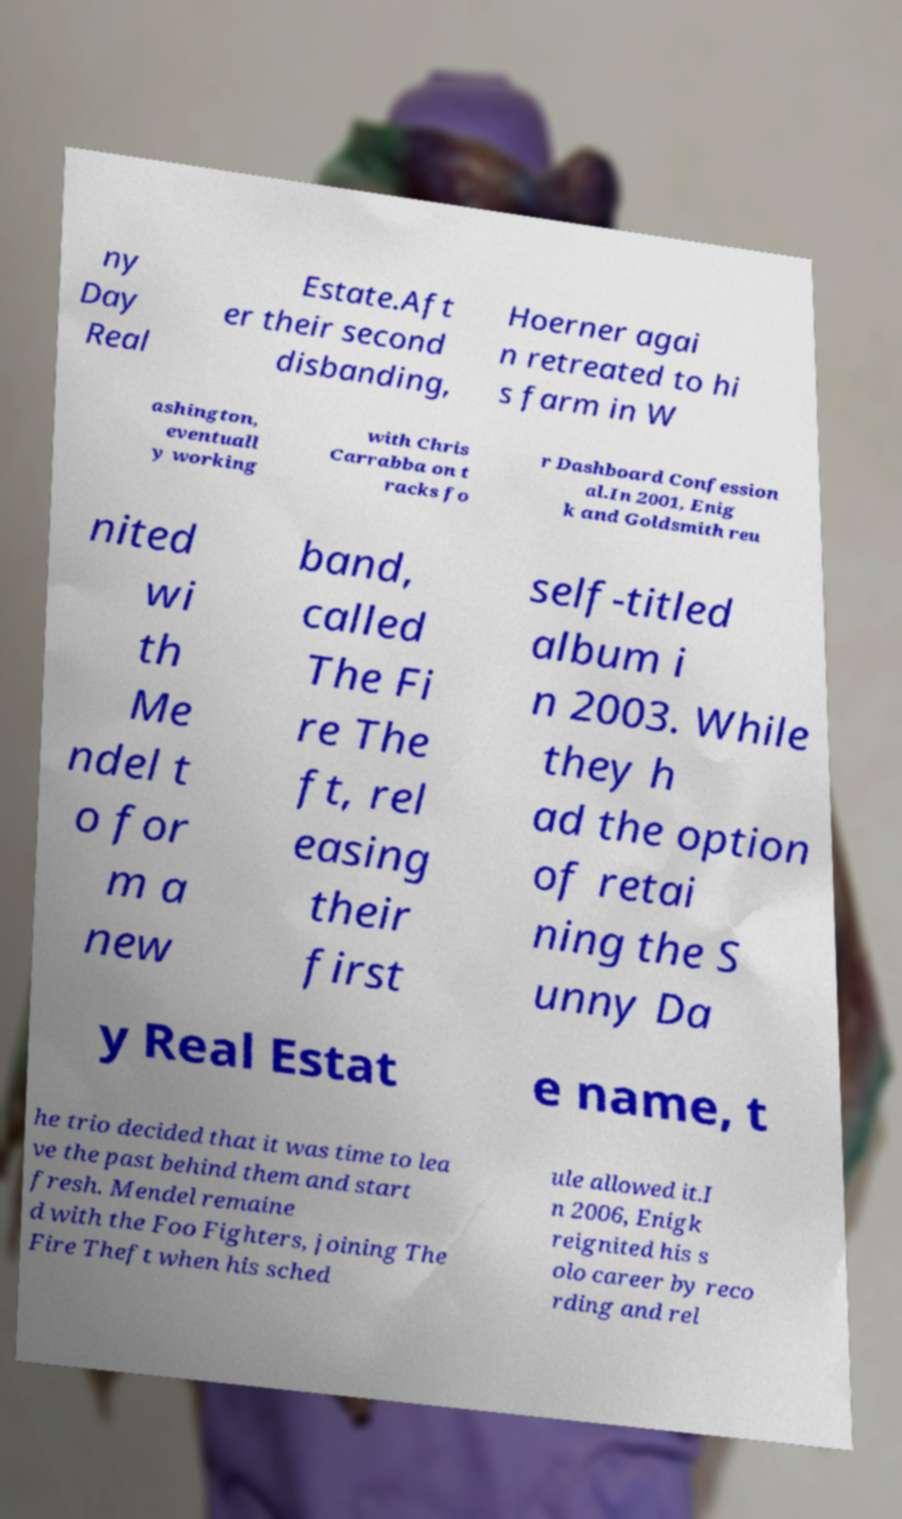Could you assist in decoding the text presented in this image and type it out clearly? ny Day Real Estate.Aft er their second disbanding, Hoerner agai n retreated to hi s farm in W ashington, eventuall y working with Chris Carrabba on t racks fo r Dashboard Confession al.In 2001, Enig k and Goldsmith reu nited wi th Me ndel t o for m a new band, called The Fi re The ft, rel easing their first self-titled album i n 2003. While they h ad the option of retai ning the S unny Da y Real Estat e name, t he trio decided that it was time to lea ve the past behind them and start fresh. Mendel remaine d with the Foo Fighters, joining The Fire Theft when his sched ule allowed it.I n 2006, Enigk reignited his s olo career by reco rding and rel 